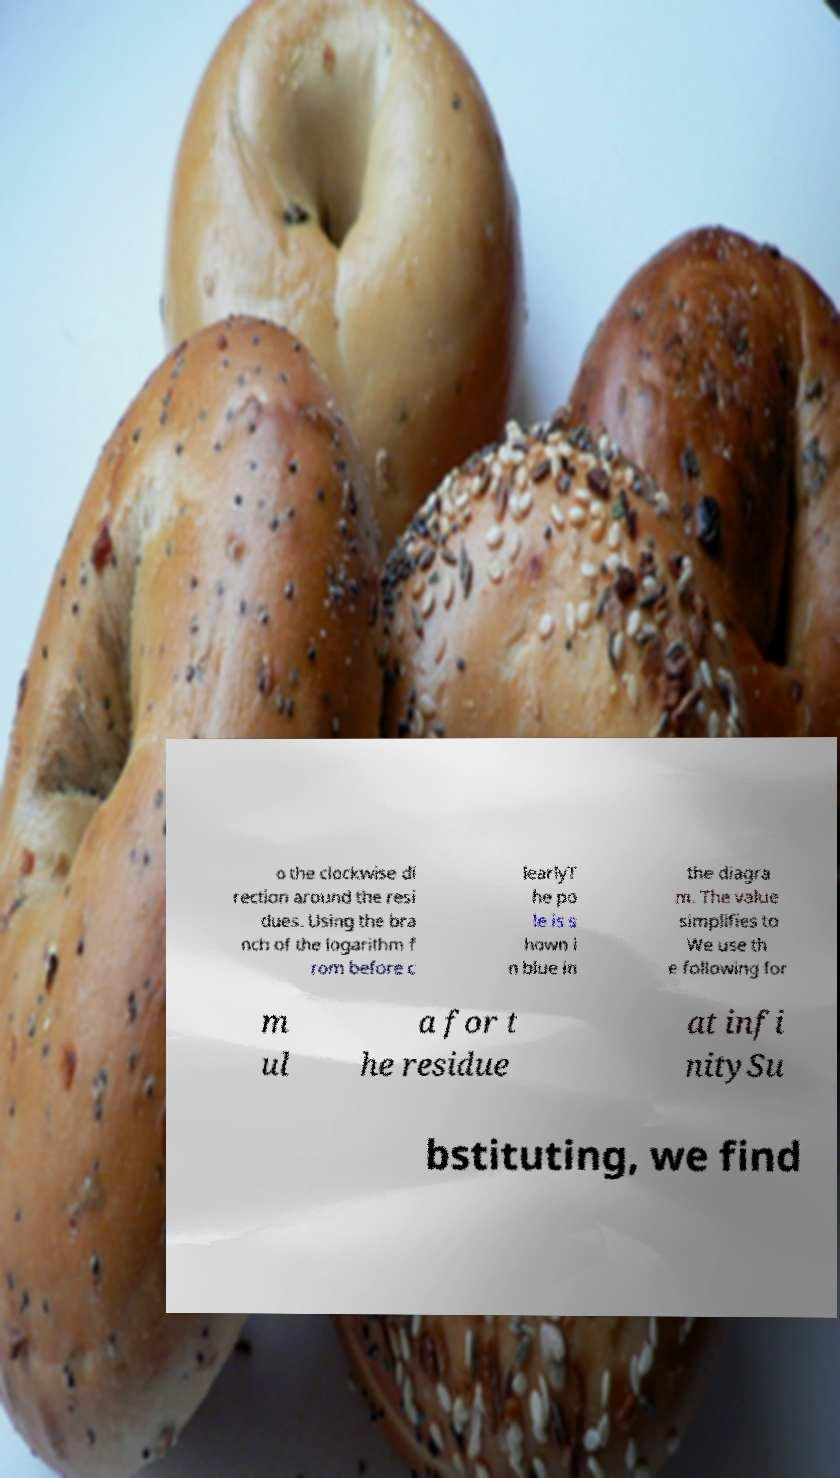Can you read and provide the text displayed in the image?This photo seems to have some interesting text. Can you extract and type it out for me? o the clockwise di rection around the resi dues. Using the bra nch of the logarithm f rom before c learlyT he po le is s hown i n blue in the diagra m. The value simplifies to We use th e following for m ul a for t he residue at infi nitySu bstituting, we find 